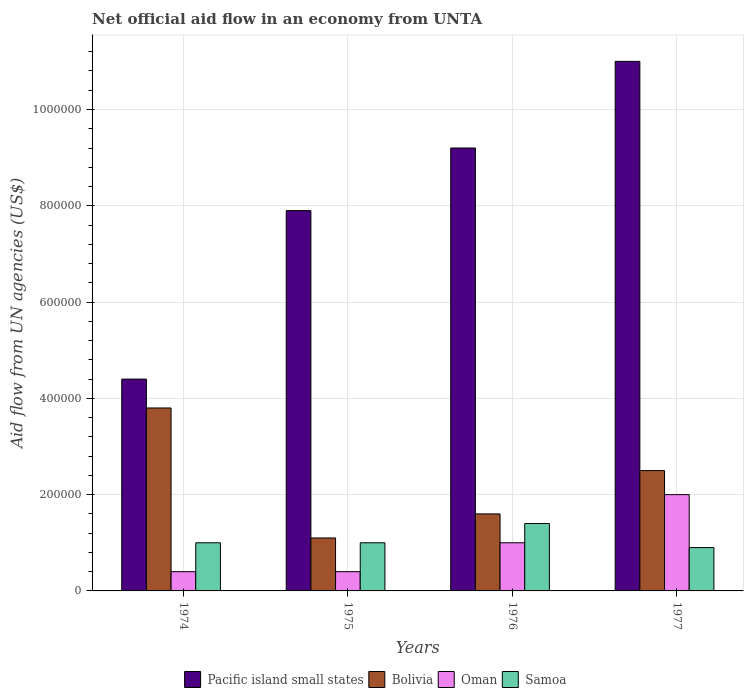Are the number of bars per tick equal to the number of legend labels?
Your answer should be compact. Yes. How many bars are there on the 1st tick from the right?
Your answer should be compact. 4. What is the label of the 1st group of bars from the left?
Ensure brevity in your answer.  1974. In how many cases, is the number of bars for a given year not equal to the number of legend labels?
Give a very brief answer. 0. Across all years, what is the minimum net official aid flow in Oman?
Give a very brief answer. 4.00e+04. In which year was the net official aid flow in Samoa maximum?
Make the answer very short. 1976. In which year was the net official aid flow in Samoa minimum?
Give a very brief answer. 1977. What is the total net official aid flow in Pacific island small states in the graph?
Ensure brevity in your answer.  3.25e+06. What is the difference between the net official aid flow in Pacific island small states in 1975 and that in 1977?
Provide a succinct answer. -3.10e+05. What is the average net official aid flow in Pacific island small states per year?
Ensure brevity in your answer.  8.12e+05. What is the ratio of the net official aid flow in Pacific island small states in 1976 to that in 1977?
Make the answer very short. 0.84. Is the difference between the net official aid flow in Bolivia in 1974 and 1975 greater than the difference between the net official aid flow in Oman in 1974 and 1975?
Offer a very short reply. Yes. What is the difference between the highest and the lowest net official aid flow in Oman?
Give a very brief answer. 1.60e+05. In how many years, is the net official aid flow in Pacific island small states greater than the average net official aid flow in Pacific island small states taken over all years?
Your response must be concise. 2. What does the 1st bar from the left in 1977 represents?
Your answer should be compact. Pacific island small states. What does the 1st bar from the right in 1975 represents?
Provide a short and direct response. Samoa. How many bars are there?
Make the answer very short. 16. Are all the bars in the graph horizontal?
Offer a very short reply. No. How many years are there in the graph?
Your response must be concise. 4. What is the difference between two consecutive major ticks on the Y-axis?
Your answer should be very brief. 2.00e+05. How many legend labels are there?
Offer a very short reply. 4. What is the title of the graph?
Your answer should be very brief. Net official aid flow in an economy from UNTA. What is the label or title of the X-axis?
Your answer should be very brief. Years. What is the label or title of the Y-axis?
Your answer should be very brief. Aid flow from UN agencies (US$). What is the Aid flow from UN agencies (US$) in Pacific island small states in 1974?
Make the answer very short. 4.40e+05. What is the Aid flow from UN agencies (US$) in Bolivia in 1974?
Ensure brevity in your answer.  3.80e+05. What is the Aid flow from UN agencies (US$) in Samoa in 1974?
Make the answer very short. 1.00e+05. What is the Aid flow from UN agencies (US$) of Pacific island small states in 1975?
Keep it short and to the point. 7.90e+05. What is the Aid flow from UN agencies (US$) in Pacific island small states in 1976?
Give a very brief answer. 9.20e+05. What is the Aid flow from UN agencies (US$) of Bolivia in 1976?
Provide a short and direct response. 1.60e+05. What is the Aid flow from UN agencies (US$) in Oman in 1976?
Offer a very short reply. 1.00e+05. What is the Aid flow from UN agencies (US$) in Samoa in 1976?
Your response must be concise. 1.40e+05. What is the Aid flow from UN agencies (US$) in Pacific island small states in 1977?
Ensure brevity in your answer.  1.10e+06. What is the Aid flow from UN agencies (US$) of Bolivia in 1977?
Keep it short and to the point. 2.50e+05. What is the Aid flow from UN agencies (US$) in Oman in 1977?
Provide a succinct answer. 2.00e+05. Across all years, what is the maximum Aid flow from UN agencies (US$) in Pacific island small states?
Your response must be concise. 1.10e+06. Across all years, what is the maximum Aid flow from UN agencies (US$) of Bolivia?
Keep it short and to the point. 3.80e+05. Across all years, what is the maximum Aid flow from UN agencies (US$) of Oman?
Make the answer very short. 2.00e+05. Across all years, what is the minimum Aid flow from UN agencies (US$) in Bolivia?
Your answer should be compact. 1.10e+05. Across all years, what is the minimum Aid flow from UN agencies (US$) of Oman?
Provide a short and direct response. 4.00e+04. Across all years, what is the minimum Aid flow from UN agencies (US$) in Samoa?
Your response must be concise. 9.00e+04. What is the total Aid flow from UN agencies (US$) in Pacific island small states in the graph?
Make the answer very short. 3.25e+06. What is the difference between the Aid flow from UN agencies (US$) of Pacific island small states in 1974 and that in 1975?
Provide a succinct answer. -3.50e+05. What is the difference between the Aid flow from UN agencies (US$) of Oman in 1974 and that in 1975?
Your response must be concise. 0. What is the difference between the Aid flow from UN agencies (US$) of Pacific island small states in 1974 and that in 1976?
Keep it short and to the point. -4.80e+05. What is the difference between the Aid flow from UN agencies (US$) of Bolivia in 1974 and that in 1976?
Offer a terse response. 2.20e+05. What is the difference between the Aid flow from UN agencies (US$) in Pacific island small states in 1974 and that in 1977?
Your response must be concise. -6.60e+05. What is the difference between the Aid flow from UN agencies (US$) of Bolivia in 1974 and that in 1977?
Offer a terse response. 1.30e+05. What is the difference between the Aid flow from UN agencies (US$) in Pacific island small states in 1975 and that in 1976?
Give a very brief answer. -1.30e+05. What is the difference between the Aid flow from UN agencies (US$) of Bolivia in 1975 and that in 1976?
Offer a very short reply. -5.00e+04. What is the difference between the Aid flow from UN agencies (US$) in Oman in 1975 and that in 1976?
Ensure brevity in your answer.  -6.00e+04. What is the difference between the Aid flow from UN agencies (US$) of Samoa in 1975 and that in 1976?
Your answer should be compact. -4.00e+04. What is the difference between the Aid flow from UN agencies (US$) in Pacific island small states in 1975 and that in 1977?
Provide a succinct answer. -3.10e+05. What is the difference between the Aid flow from UN agencies (US$) of Bolivia in 1975 and that in 1977?
Offer a terse response. -1.40e+05. What is the difference between the Aid flow from UN agencies (US$) of Oman in 1975 and that in 1977?
Ensure brevity in your answer.  -1.60e+05. What is the difference between the Aid flow from UN agencies (US$) of Pacific island small states in 1976 and that in 1977?
Offer a very short reply. -1.80e+05. What is the difference between the Aid flow from UN agencies (US$) in Oman in 1976 and that in 1977?
Give a very brief answer. -1.00e+05. What is the difference between the Aid flow from UN agencies (US$) in Samoa in 1976 and that in 1977?
Give a very brief answer. 5.00e+04. What is the difference between the Aid flow from UN agencies (US$) in Pacific island small states in 1974 and the Aid flow from UN agencies (US$) in Oman in 1975?
Ensure brevity in your answer.  4.00e+05. What is the difference between the Aid flow from UN agencies (US$) of Oman in 1974 and the Aid flow from UN agencies (US$) of Samoa in 1975?
Your answer should be compact. -6.00e+04. What is the difference between the Aid flow from UN agencies (US$) in Pacific island small states in 1974 and the Aid flow from UN agencies (US$) in Bolivia in 1976?
Make the answer very short. 2.80e+05. What is the difference between the Aid flow from UN agencies (US$) of Bolivia in 1974 and the Aid flow from UN agencies (US$) of Samoa in 1976?
Give a very brief answer. 2.40e+05. What is the difference between the Aid flow from UN agencies (US$) of Pacific island small states in 1974 and the Aid flow from UN agencies (US$) of Bolivia in 1977?
Your answer should be very brief. 1.90e+05. What is the difference between the Aid flow from UN agencies (US$) of Pacific island small states in 1974 and the Aid flow from UN agencies (US$) of Oman in 1977?
Ensure brevity in your answer.  2.40e+05. What is the difference between the Aid flow from UN agencies (US$) in Bolivia in 1974 and the Aid flow from UN agencies (US$) in Oman in 1977?
Your response must be concise. 1.80e+05. What is the difference between the Aid flow from UN agencies (US$) in Oman in 1974 and the Aid flow from UN agencies (US$) in Samoa in 1977?
Your answer should be compact. -5.00e+04. What is the difference between the Aid flow from UN agencies (US$) in Pacific island small states in 1975 and the Aid flow from UN agencies (US$) in Bolivia in 1976?
Offer a terse response. 6.30e+05. What is the difference between the Aid flow from UN agencies (US$) of Pacific island small states in 1975 and the Aid flow from UN agencies (US$) of Oman in 1976?
Provide a succinct answer. 6.90e+05. What is the difference between the Aid flow from UN agencies (US$) of Pacific island small states in 1975 and the Aid flow from UN agencies (US$) of Samoa in 1976?
Offer a very short reply. 6.50e+05. What is the difference between the Aid flow from UN agencies (US$) of Oman in 1975 and the Aid flow from UN agencies (US$) of Samoa in 1976?
Make the answer very short. -1.00e+05. What is the difference between the Aid flow from UN agencies (US$) of Pacific island small states in 1975 and the Aid flow from UN agencies (US$) of Bolivia in 1977?
Your response must be concise. 5.40e+05. What is the difference between the Aid flow from UN agencies (US$) in Pacific island small states in 1975 and the Aid flow from UN agencies (US$) in Oman in 1977?
Offer a terse response. 5.90e+05. What is the difference between the Aid flow from UN agencies (US$) in Pacific island small states in 1975 and the Aid flow from UN agencies (US$) in Samoa in 1977?
Provide a short and direct response. 7.00e+05. What is the difference between the Aid flow from UN agencies (US$) in Bolivia in 1975 and the Aid flow from UN agencies (US$) in Oman in 1977?
Your answer should be compact. -9.00e+04. What is the difference between the Aid flow from UN agencies (US$) in Pacific island small states in 1976 and the Aid flow from UN agencies (US$) in Bolivia in 1977?
Offer a terse response. 6.70e+05. What is the difference between the Aid flow from UN agencies (US$) of Pacific island small states in 1976 and the Aid flow from UN agencies (US$) of Oman in 1977?
Your response must be concise. 7.20e+05. What is the difference between the Aid flow from UN agencies (US$) in Pacific island small states in 1976 and the Aid flow from UN agencies (US$) in Samoa in 1977?
Give a very brief answer. 8.30e+05. What is the average Aid flow from UN agencies (US$) in Pacific island small states per year?
Your answer should be very brief. 8.12e+05. What is the average Aid flow from UN agencies (US$) in Bolivia per year?
Your answer should be compact. 2.25e+05. What is the average Aid flow from UN agencies (US$) in Oman per year?
Provide a succinct answer. 9.50e+04. What is the average Aid flow from UN agencies (US$) of Samoa per year?
Your answer should be very brief. 1.08e+05. In the year 1974, what is the difference between the Aid flow from UN agencies (US$) of Pacific island small states and Aid flow from UN agencies (US$) of Oman?
Offer a terse response. 4.00e+05. In the year 1974, what is the difference between the Aid flow from UN agencies (US$) in Pacific island small states and Aid flow from UN agencies (US$) in Samoa?
Keep it short and to the point. 3.40e+05. In the year 1974, what is the difference between the Aid flow from UN agencies (US$) of Bolivia and Aid flow from UN agencies (US$) of Oman?
Offer a terse response. 3.40e+05. In the year 1975, what is the difference between the Aid flow from UN agencies (US$) of Pacific island small states and Aid flow from UN agencies (US$) of Bolivia?
Your answer should be very brief. 6.80e+05. In the year 1975, what is the difference between the Aid flow from UN agencies (US$) of Pacific island small states and Aid flow from UN agencies (US$) of Oman?
Ensure brevity in your answer.  7.50e+05. In the year 1975, what is the difference between the Aid flow from UN agencies (US$) in Pacific island small states and Aid flow from UN agencies (US$) in Samoa?
Your answer should be compact. 6.90e+05. In the year 1975, what is the difference between the Aid flow from UN agencies (US$) of Bolivia and Aid flow from UN agencies (US$) of Samoa?
Provide a short and direct response. 10000. In the year 1976, what is the difference between the Aid flow from UN agencies (US$) in Pacific island small states and Aid flow from UN agencies (US$) in Bolivia?
Offer a terse response. 7.60e+05. In the year 1976, what is the difference between the Aid flow from UN agencies (US$) in Pacific island small states and Aid flow from UN agencies (US$) in Oman?
Offer a terse response. 8.20e+05. In the year 1976, what is the difference between the Aid flow from UN agencies (US$) in Pacific island small states and Aid flow from UN agencies (US$) in Samoa?
Ensure brevity in your answer.  7.80e+05. In the year 1977, what is the difference between the Aid flow from UN agencies (US$) of Pacific island small states and Aid flow from UN agencies (US$) of Bolivia?
Provide a succinct answer. 8.50e+05. In the year 1977, what is the difference between the Aid flow from UN agencies (US$) in Pacific island small states and Aid flow from UN agencies (US$) in Samoa?
Ensure brevity in your answer.  1.01e+06. In the year 1977, what is the difference between the Aid flow from UN agencies (US$) of Bolivia and Aid flow from UN agencies (US$) of Samoa?
Offer a very short reply. 1.60e+05. In the year 1977, what is the difference between the Aid flow from UN agencies (US$) in Oman and Aid flow from UN agencies (US$) in Samoa?
Give a very brief answer. 1.10e+05. What is the ratio of the Aid flow from UN agencies (US$) in Pacific island small states in 1974 to that in 1975?
Your answer should be compact. 0.56. What is the ratio of the Aid flow from UN agencies (US$) of Bolivia in 1974 to that in 1975?
Your answer should be very brief. 3.45. What is the ratio of the Aid flow from UN agencies (US$) of Oman in 1974 to that in 1975?
Provide a succinct answer. 1. What is the ratio of the Aid flow from UN agencies (US$) in Samoa in 1974 to that in 1975?
Your answer should be compact. 1. What is the ratio of the Aid flow from UN agencies (US$) in Pacific island small states in 1974 to that in 1976?
Your answer should be very brief. 0.48. What is the ratio of the Aid flow from UN agencies (US$) in Bolivia in 1974 to that in 1976?
Your response must be concise. 2.38. What is the ratio of the Aid flow from UN agencies (US$) of Bolivia in 1974 to that in 1977?
Give a very brief answer. 1.52. What is the ratio of the Aid flow from UN agencies (US$) of Pacific island small states in 1975 to that in 1976?
Your response must be concise. 0.86. What is the ratio of the Aid flow from UN agencies (US$) in Bolivia in 1975 to that in 1976?
Your answer should be compact. 0.69. What is the ratio of the Aid flow from UN agencies (US$) in Samoa in 1975 to that in 1976?
Offer a very short reply. 0.71. What is the ratio of the Aid flow from UN agencies (US$) of Pacific island small states in 1975 to that in 1977?
Offer a terse response. 0.72. What is the ratio of the Aid flow from UN agencies (US$) of Bolivia in 1975 to that in 1977?
Make the answer very short. 0.44. What is the ratio of the Aid flow from UN agencies (US$) of Pacific island small states in 1976 to that in 1977?
Ensure brevity in your answer.  0.84. What is the ratio of the Aid flow from UN agencies (US$) of Bolivia in 1976 to that in 1977?
Offer a terse response. 0.64. What is the ratio of the Aid flow from UN agencies (US$) of Samoa in 1976 to that in 1977?
Keep it short and to the point. 1.56. What is the difference between the highest and the second highest Aid flow from UN agencies (US$) in Pacific island small states?
Your response must be concise. 1.80e+05. What is the difference between the highest and the second highest Aid flow from UN agencies (US$) of Samoa?
Keep it short and to the point. 4.00e+04. What is the difference between the highest and the lowest Aid flow from UN agencies (US$) of Bolivia?
Make the answer very short. 2.70e+05. What is the difference between the highest and the lowest Aid flow from UN agencies (US$) in Oman?
Offer a very short reply. 1.60e+05. 